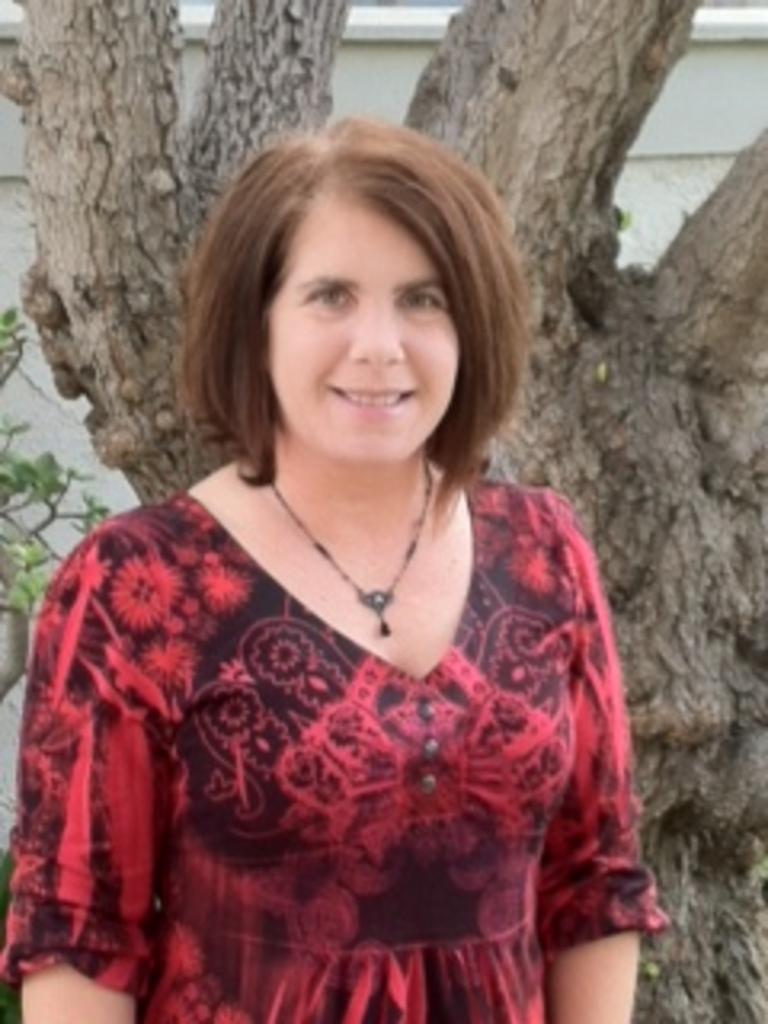What is the woman in the image wearing? The woman is wearing a red dress. What is the woman's expression in the image? The woman is standing and smiling in the image. What can be seen in the background of the image? There is a tree trunk and a wall in the background of the image. How does the woman's pocket contribute to the overall composition of the image? There is no mention of a pocket in the provided facts, so it cannot be determined how it contributes to the image. 